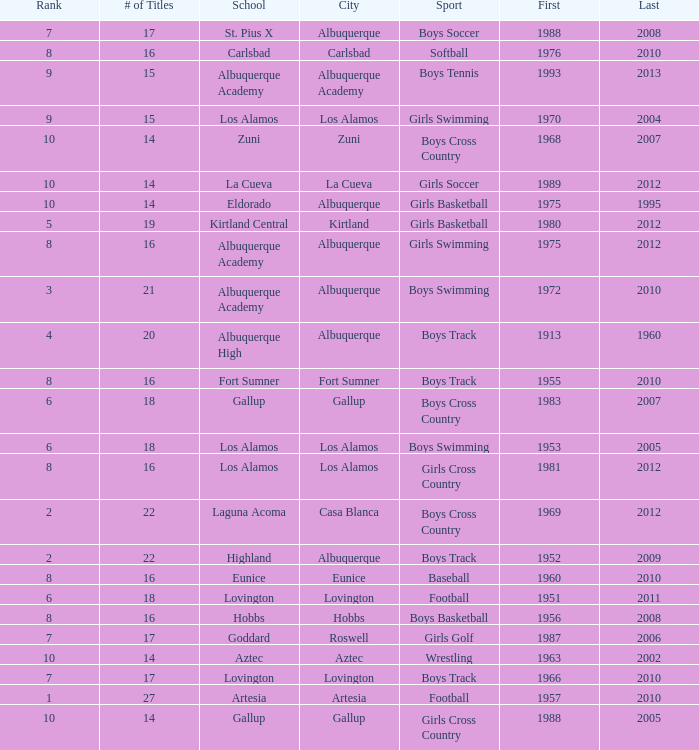What is the total rank number for Los Alamos' girls cross country? 1.0. 